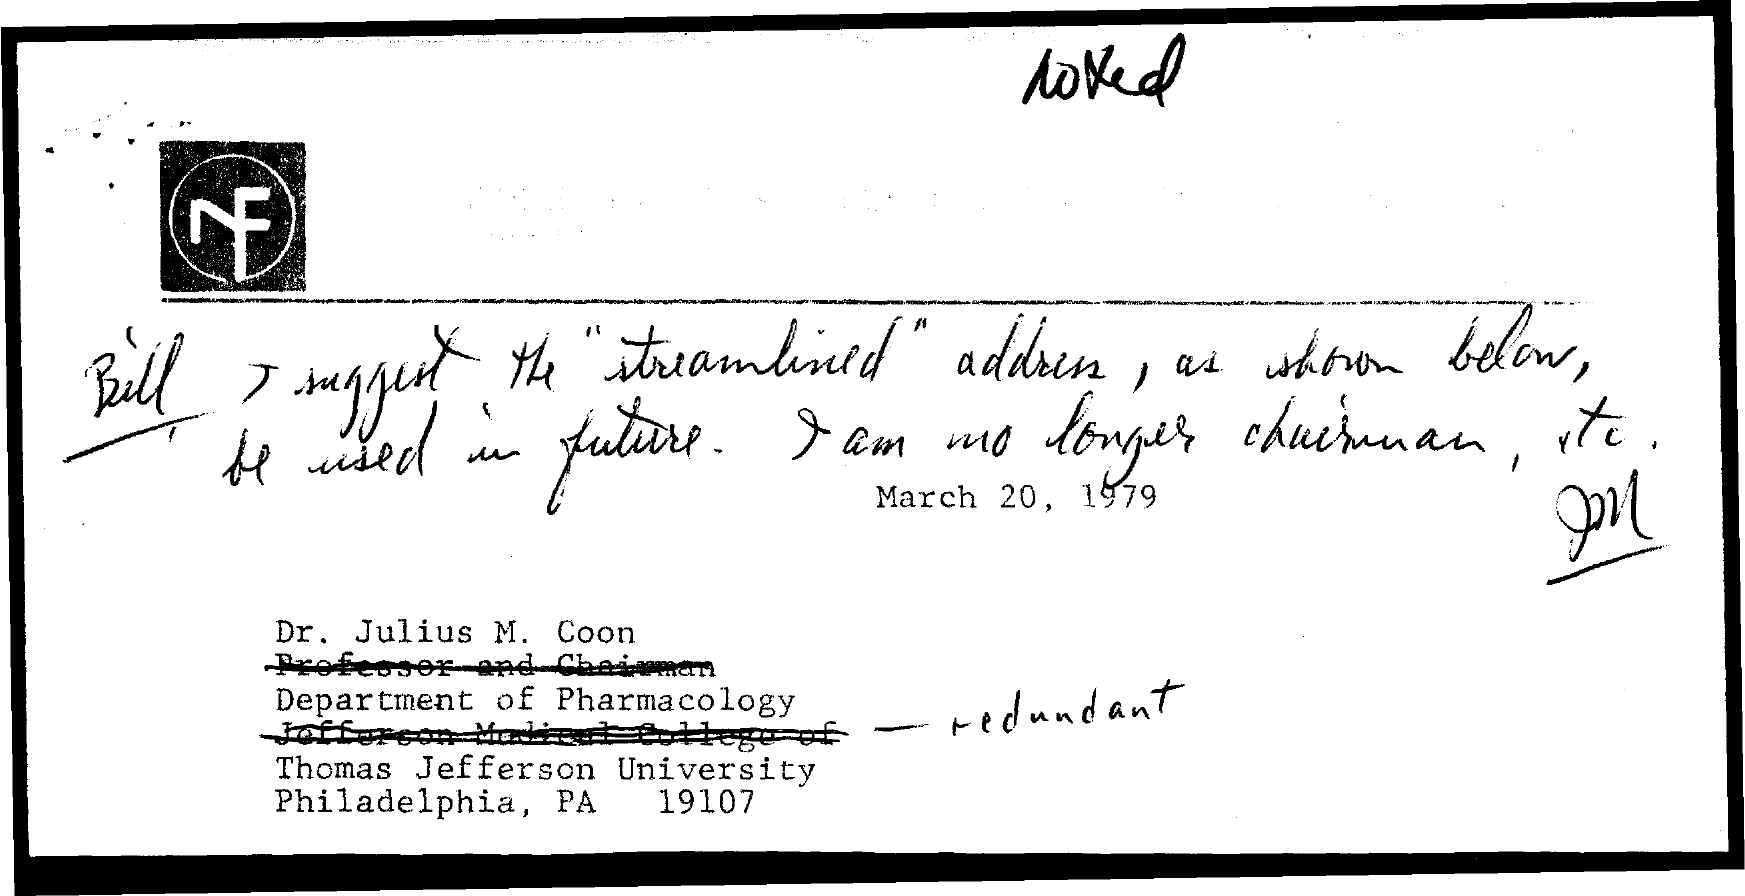Mention a couple of crucial points in this snapshot. The document provides information about a date, which is March 20, 1979. Dr. Julius M. Coon is a member of Thomas Jefferson University. Dr. Julius M. Coon is affiliated with the Department of Pharmacology. 